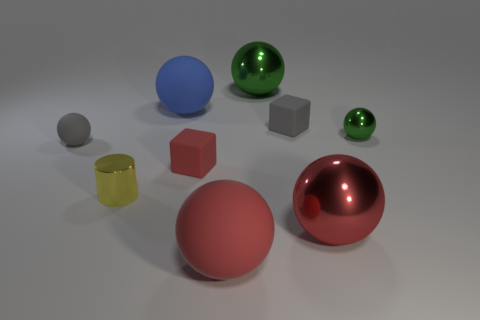The big red object that is the same material as the gray cube is what shape?
Make the answer very short. Sphere. What number of blue things are either big matte cylinders or big rubber spheres?
Provide a succinct answer. 1. There is a metallic object behind the matte thing on the right side of the big green ball; are there any red matte blocks that are behind it?
Your answer should be compact. No. Are there fewer small yellow shiny cylinders than red metal blocks?
Make the answer very short. No. There is a large metal object that is behind the tiny green ball; is it the same shape as the small yellow metallic object?
Provide a short and direct response. No. Is there a yellow metal cylinder?
Give a very brief answer. Yes. The metal sphere in front of the tiny green shiny sphere behind the tiny yellow thing that is in front of the tiny gray rubber block is what color?
Offer a terse response. Red. Are there an equal number of tiny rubber blocks in front of the tiny yellow object and metal balls behind the tiny gray matte ball?
Give a very brief answer. No. What shape is the green shiny thing that is the same size as the yellow cylinder?
Make the answer very short. Sphere. Is there a rubber object of the same color as the small rubber sphere?
Ensure brevity in your answer.  Yes. 